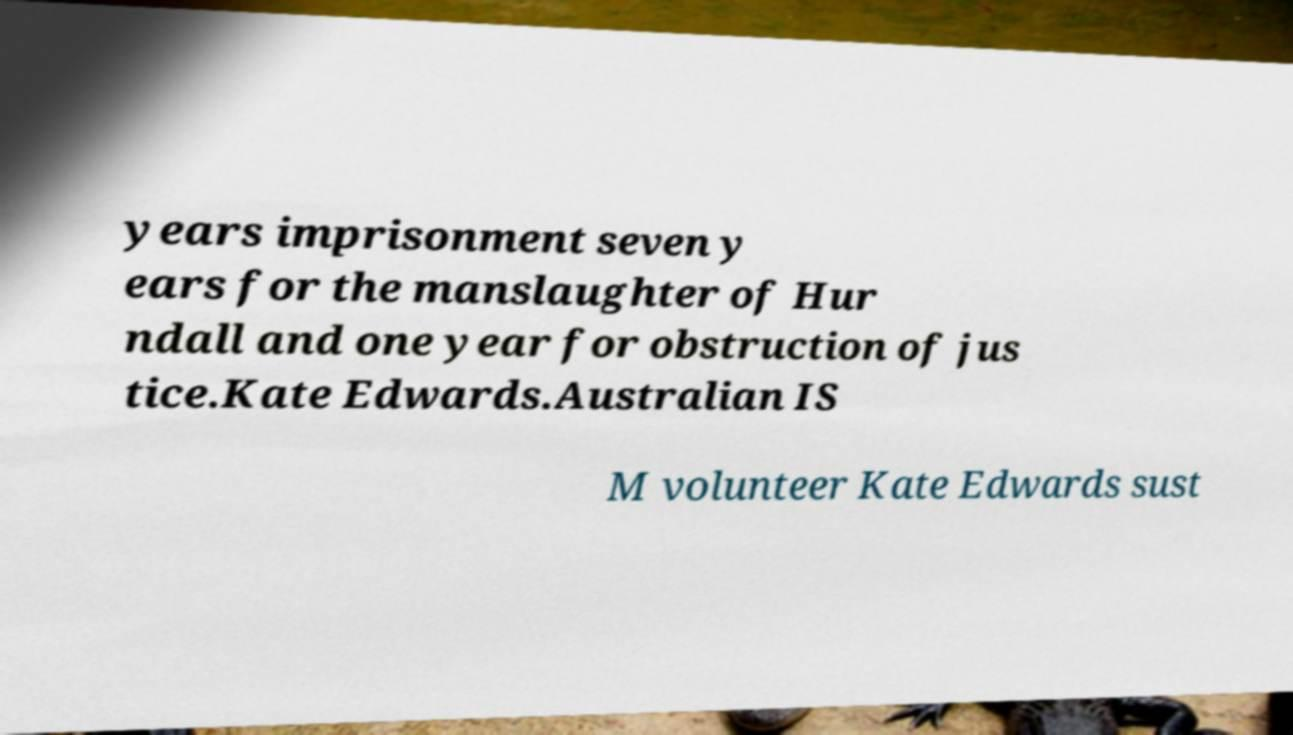Can you accurately transcribe the text from the provided image for me? years imprisonment seven y ears for the manslaughter of Hur ndall and one year for obstruction of jus tice.Kate Edwards.Australian IS M volunteer Kate Edwards sust 